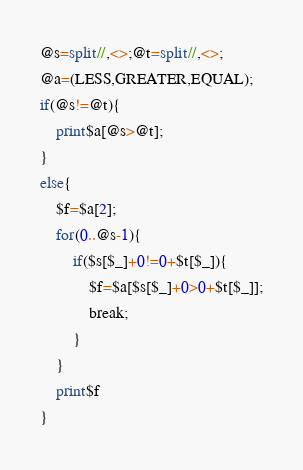<code> <loc_0><loc_0><loc_500><loc_500><_Perl_>@s=split//,<>;@t=split//,<>;
@a=(LESS,GREATER,EQUAL);
if(@s!=@t){
	print$a[@s>@t];
}
else{
	$f=$a[2];
	for(0..@s-1){
		if($s[$_]+0!=0+$t[$_]){
			$f=$a[$s[$_]+0>0+$t[$_]];
			break;
		}
	}
	print$f
}
</code> 